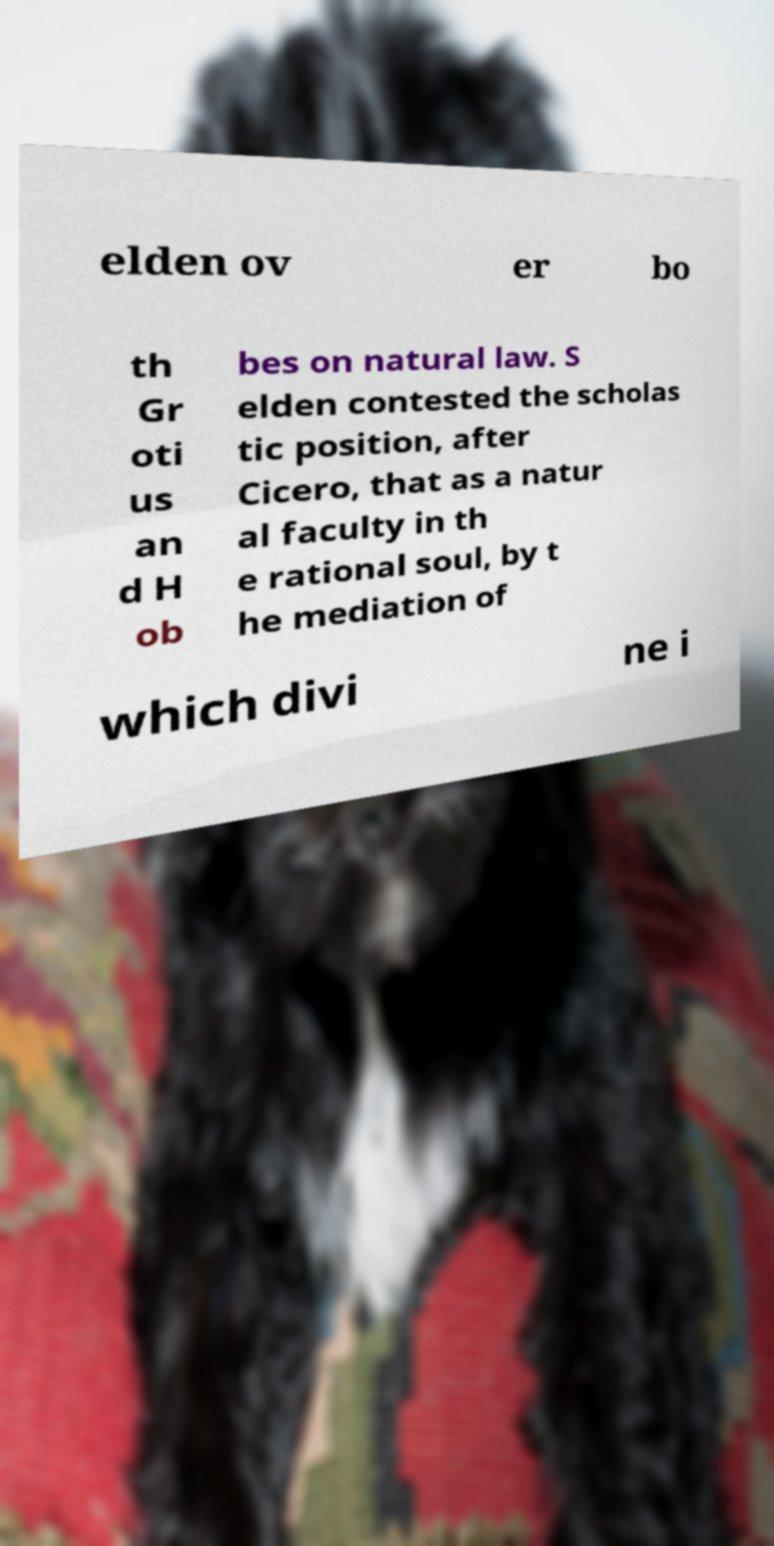What messages or text are displayed in this image? I need them in a readable, typed format. elden ov er bo th Gr oti us an d H ob bes on natural law. S elden contested the scholas tic position, after Cicero, that as a natur al faculty in th e rational soul, by t he mediation of which divi ne i 